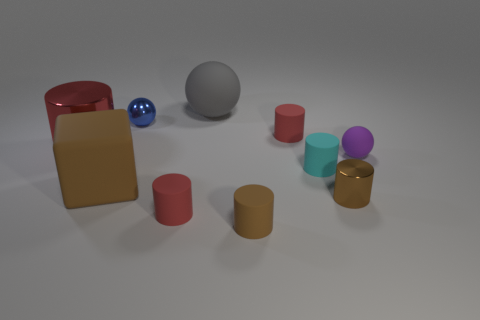Can you tell me more about the lighting in the scene? The lighting in the image creates soft shadows and gives a diffuse, gentle appearance. It appears to be evenly distributed, perhaps coming from an overhead source, and it creates a calm, neutral setting for the objects depicted. 